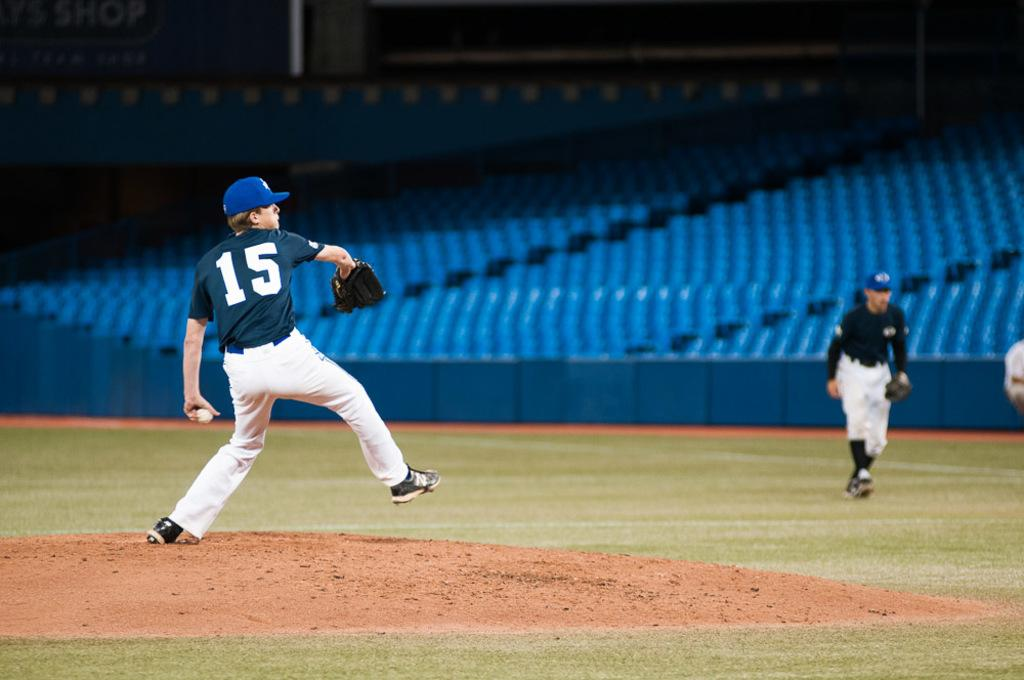What activity is taking place in the stadium in the image? There are persons playing in the stadium. How many people are visible in the image? The number of people is not specified, but there are persons playing in the stadium. What can be seen in the background of the image? There are empty seats in the background. What type of surface is on the ground in the center of the image? There is grass on the ground in the center of the image. What type of chair is floating in the air in the image? There is no chair or floating object present in the image. Can you describe the insects flying around the persons playing in the image? There is no mention of insects in the image; it only shows persons playing in the stadium. 